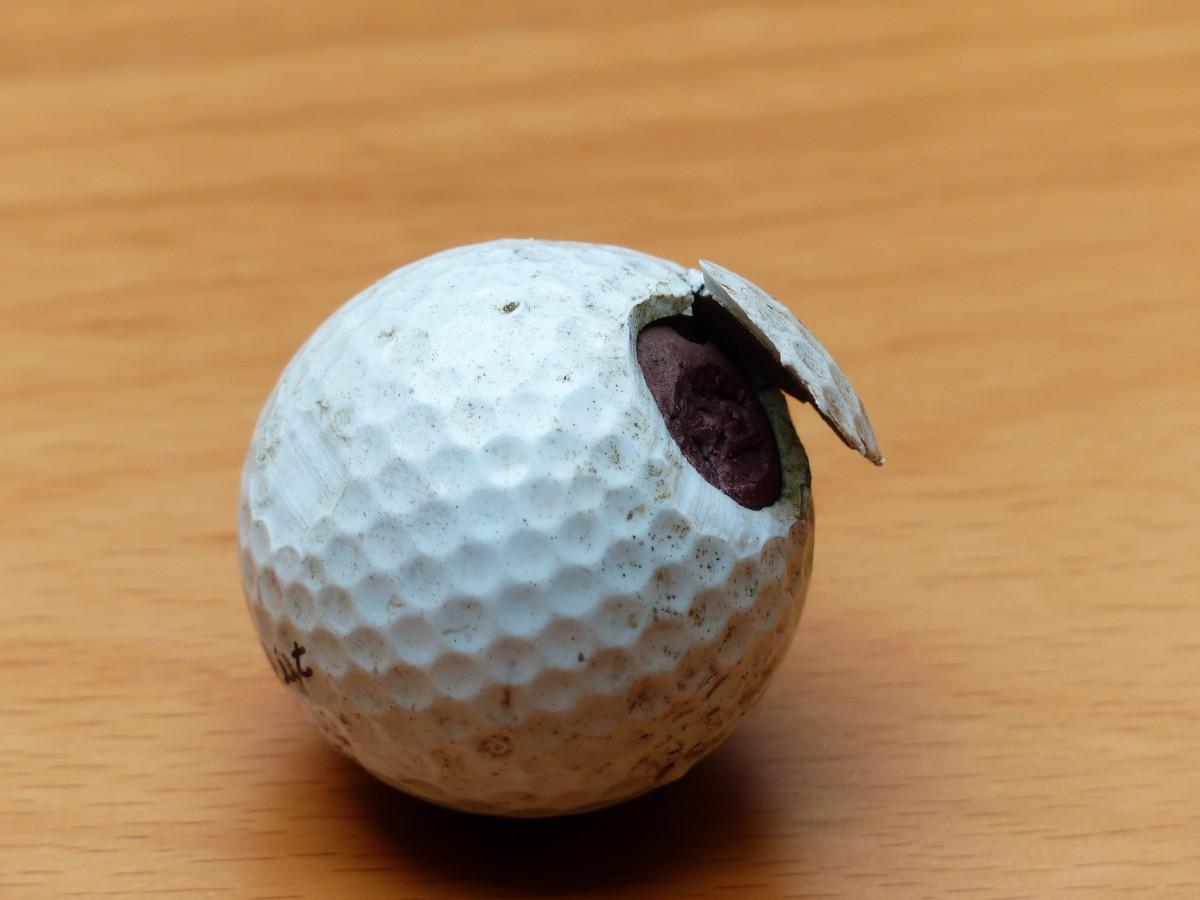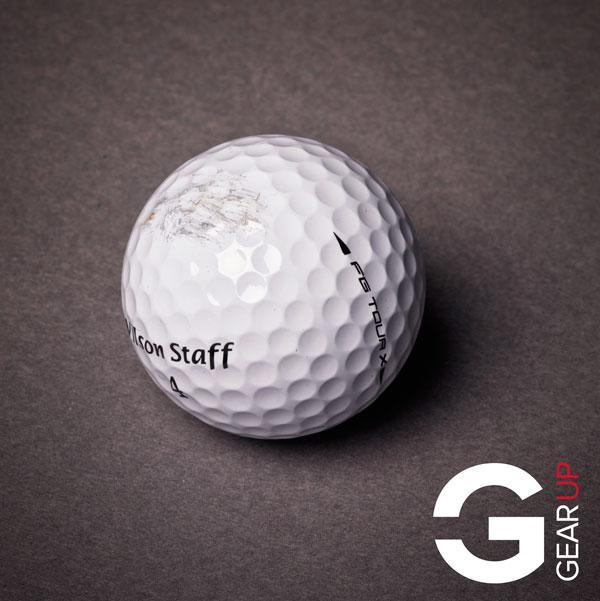The first image is the image on the left, the second image is the image on the right. Examine the images to the left and right. Is the description "Part of a hand is touching one real golf ball in the lefthand image." accurate? Answer yes or no. No. The first image is the image on the left, the second image is the image on the right. Considering the images on both sides, is "The left and right image contains the same number of golf balls with at least one in a person's hand." valid? Answer yes or no. No. 